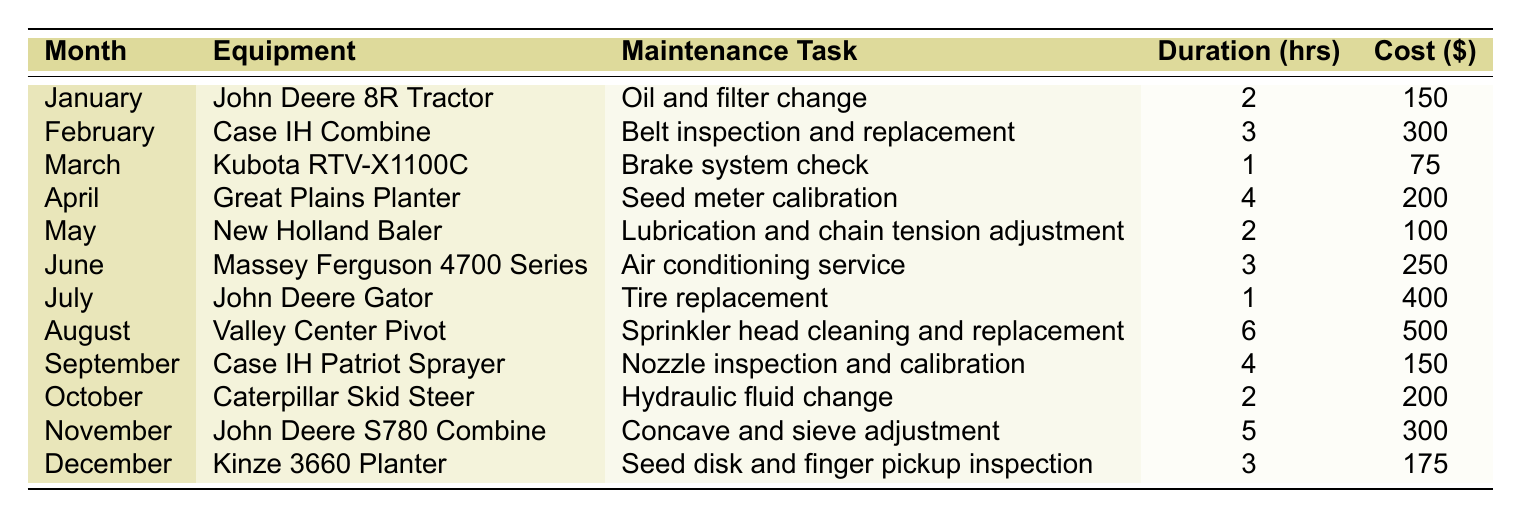What maintenance task is scheduled for the Kubota RTV-X1100C? The table lists the maintenance tasks for each piece of equipment by month. For the Kubota RTV-X1100C, the task is "Brake system check" in March.
Answer: Brake system check Which equipment requires a tire replacement? By looking through the table, the John Deere Gator in July is the equipment that requires a tire replacement.
Answer: John Deere Gator What is the total cost for the maintenance tasks scheduled in May and June? In May, the maintenance cost is $100 for the New Holland Baler, and in June, it is $250 for the Massey Ferguson 4700 Series. Summing these costs: 100 + 250 = 350 gives a total of $350.
Answer: 350 Is there a maintenance task that costs more than $400? By examining the costs listed in the table, the tire replacement for the John Deere Gator has a cost of $400, but no maintenance task exceeds this amount. Thus, the answer is no.
Answer: No Which month has the highest estimated maintenance cost? The table must be reviewed for costs associated with each month. August has the highest cost at $500 for the Valley Center Pivot. Therefore, the answer is August.
Answer: August What is the average estimated duration of the maintenance tasks over the year? The total estimated duration for all tasks can be found by adding: 2 + 3 + 1 + 4 + 2 + 3 + 1 + 6 + 4 + 2 + 5 + 3 = 32. Since there are 12 months and tasks, the average duration is 32 / 12 = approximately 2.67 hours.
Answer: Approximately 2.67 hours Are there any months in which more than one maintenance task is scheduled? The table only gives one maintenance task per month. Each month has a unique task assigned. Therefore, the answer is no.
Answer: No What is the total estimated cost for the maintenance tasks that take 3 hours or more? We identify tasks in the table taking 3 or more hours: February ($300), June ($250), August ($500), September ($150), November ($300). Adding these gives: 300 + 250 + 500 + 150 + 300 = 1500.
Answer: 1500 What maintenance task is required for the John Deere S780 Combine, and how much does it cost? By locating the John Deere S780 Combine in November, we find that the maintenance task is "Concave and sieve adjustment," and it costs $300.
Answer: Concave and sieve adjustment, $300 How much more does the maintenance task for the Valley Center Pivot cost compared to the task for the Kubota RTV-X1100C? The Valley Center Pivot costs $500 while the Kubota RTV-X1100C costs $75. Calculating the difference: 500 - 75 = 425.
Answer: 425 